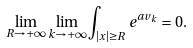<formula> <loc_0><loc_0><loc_500><loc_500>\lim _ { R \to + \infty } \lim _ { k \to + \infty } \int _ { | x | \geq R } e ^ { a v _ { k } } = 0 .</formula> 